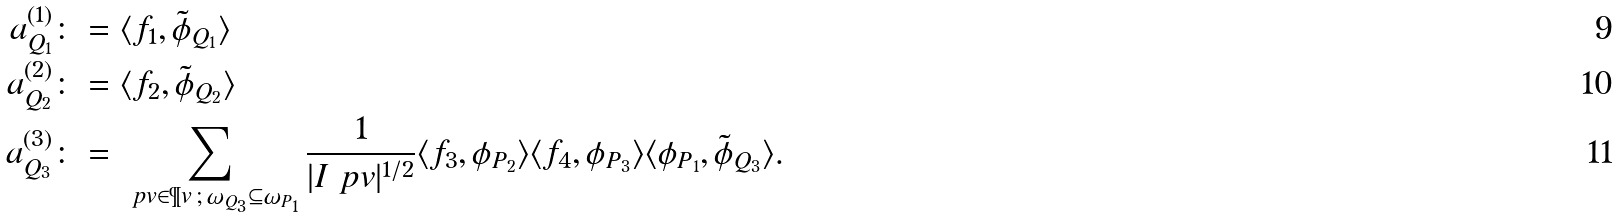Convert formula to latex. <formula><loc_0><loc_0><loc_500><loc_500>a ^ { ( 1 ) } _ { Q _ { 1 } } & \colon = \langle f _ { 1 } , \tilde { \phi } _ { Q _ { 1 } } \rangle \\ a ^ { ( 2 ) } _ { Q _ { 2 } } & \colon = \langle f _ { 2 } , \tilde { \phi } _ { Q _ { 2 } } \rangle \\ a ^ { ( 3 ) } _ { Q _ { 3 } } & \colon = \sum _ { \ p v \in \P v \, ; \, \omega _ { Q _ { 3 } } \subseteq \omega _ { P _ { 1 } } } \frac { 1 } { | I _ { \ } p v | ^ { 1 / 2 } } \langle f _ { 3 } , \phi _ { P _ { 2 } } \rangle \langle f _ { 4 } , \phi _ { P _ { 3 } } \rangle \langle \phi _ { P _ { 1 } } , \tilde { \phi } _ { Q _ { 3 } } \rangle .</formula> 